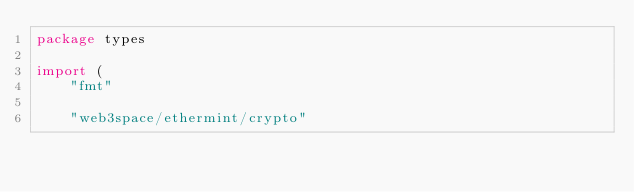Convert code to text. <code><loc_0><loc_0><loc_500><loc_500><_Go_>package types

import (
	"fmt"

	"web3space/ethermint/crypto"</code> 